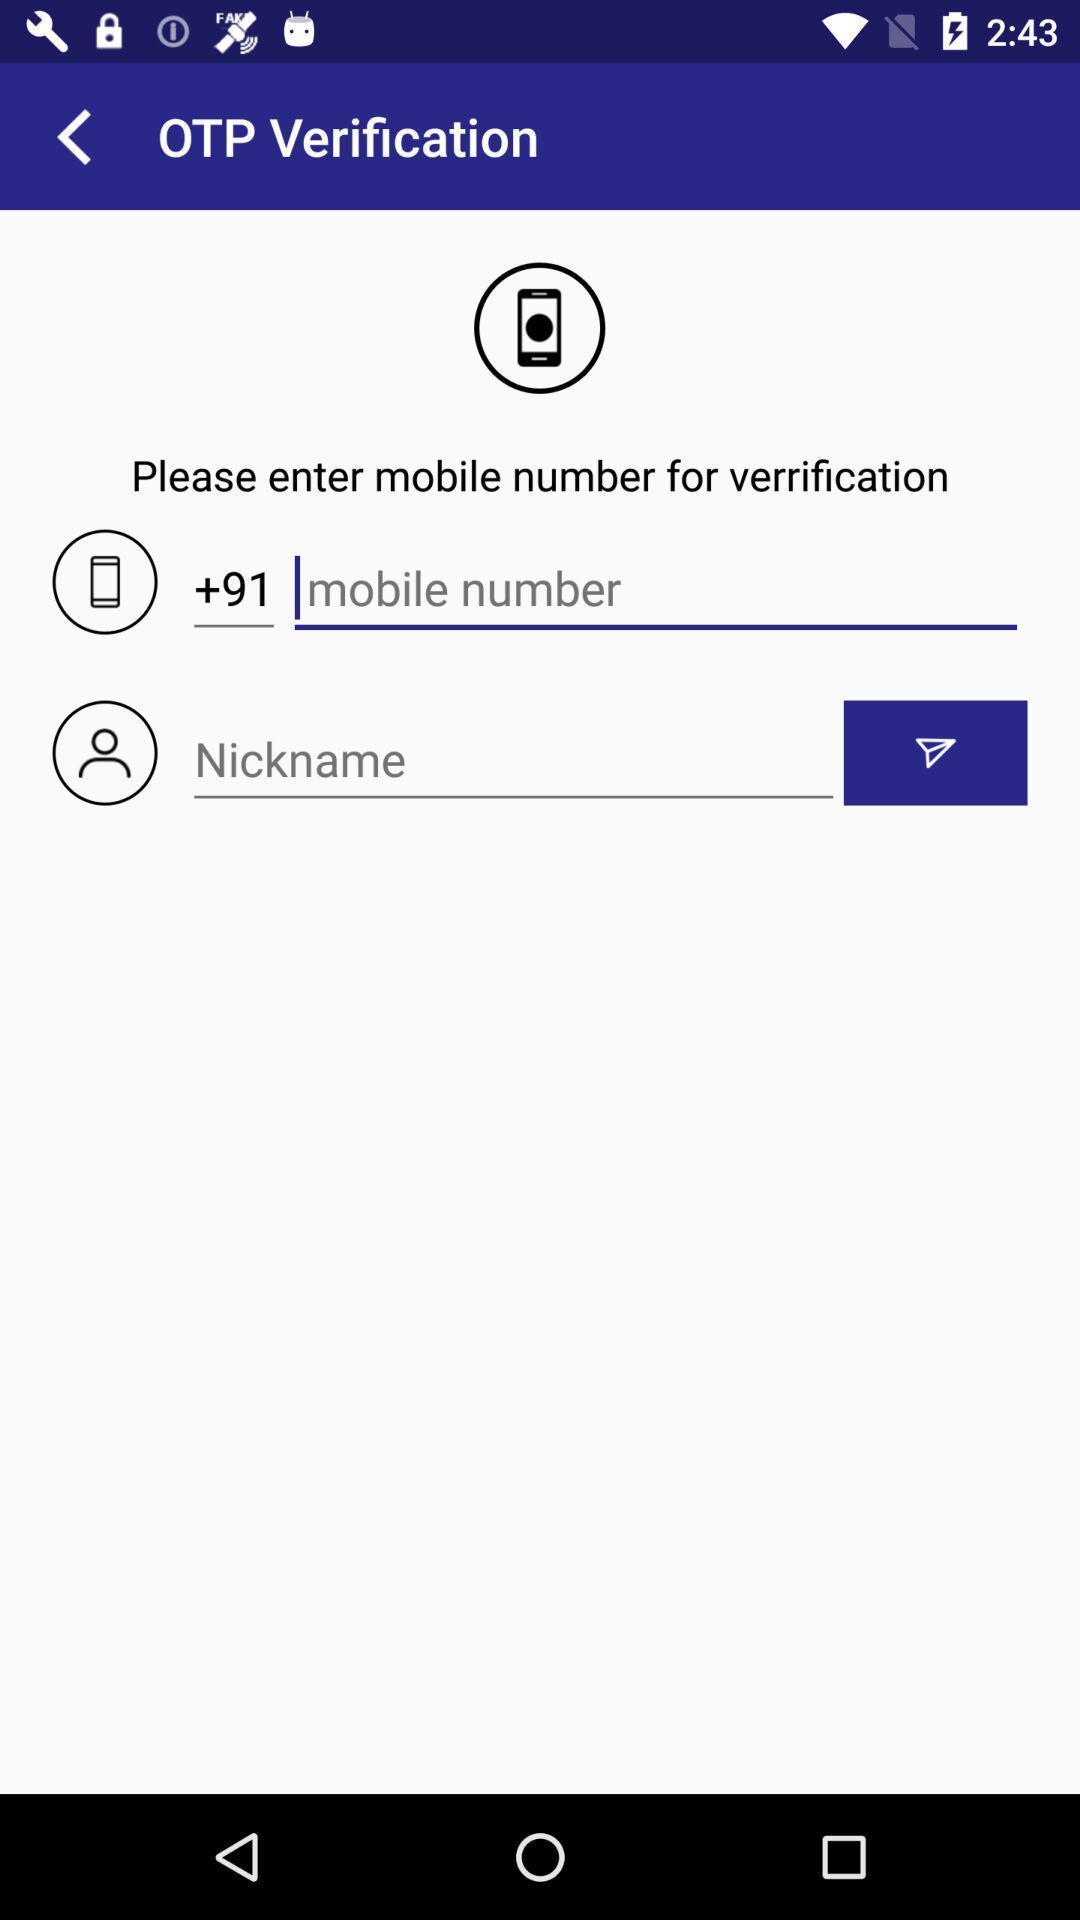What details can you identify in this image? Page to enter a number for verification. 